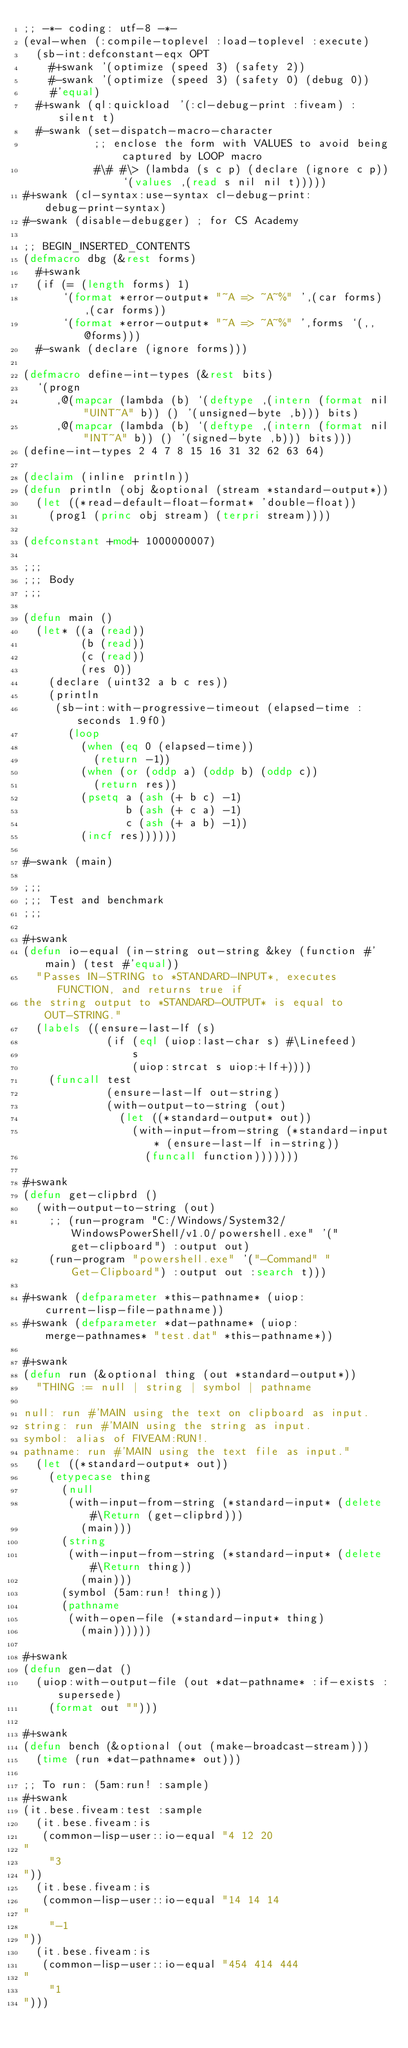Convert code to text. <code><loc_0><loc_0><loc_500><loc_500><_Lisp_>;; -*- coding: utf-8 -*-
(eval-when (:compile-toplevel :load-toplevel :execute)
  (sb-int:defconstant-eqx OPT
    #+swank '(optimize (speed 3) (safety 2))
    #-swank '(optimize (speed 3) (safety 0) (debug 0))
    #'equal)
  #+swank (ql:quickload '(:cl-debug-print :fiveam) :silent t)
  #-swank (set-dispatch-macro-character
           ;; enclose the form with VALUES to avoid being captured by LOOP macro
           #\# #\> (lambda (s c p) (declare (ignore c p)) `(values ,(read s nil nil t)))))
#+swank (cl-syntax:use-syntax cl-debug-print:debug-print-syntax)
#-swank (disable-debugger) ; for CS Academy

;; BEGIN_INSERTED_CONTENTS
(defmacro dbg (&rest forms)
  #+swank
  (if (= (length forms) 1)
      `(format *error-output* "~A => ~A~%" ',(car forms) ,(car forms))
      `(format *error-output* "~A => ~A~%" ',forms `(,,@forms)))
  #-swank (declare (ignore forms)))

(defmacro define-int-types (&rest bits)
  `(progn
     ,@(mapcar (lambda (b) `(deftype ,(intern (format nil "UINT~A" b)) () '(unsigned-byte ,b))) bits)
     ,@(mapcar (lambda (b) `(deftype ,(intern (format nil "INT~A" b)) () '(signed-byte ,b))) bits)))
(define-int-types 2 4 7 8 15 16 31 32 62 63 64)

(declaim (inline println))
(defun println (obj &optional (stream *standard-output*))
  (let ((*read-default-float-format* 'double-float))
    (prog1 (princ obj stream) (terpri stream))))

(defconstant +mod+ 1000000007)

;;;
;;; Body
;;;

(defun main ()
  (let* ((a (read))
         (b (read))
         (c (read))
         (res 0))
    (declare (uint32 a b c res))
    (println
     (sb-int:with-progressive-timeout (elapsed-time :seconds 1.9f0)
       (loop
         (when (eq 0 (elapsed-time))
           (return -1))
         (when (or (oddp a) (oddp b) (oddp c))
           (return res))
         (psetq a (ash (+ b c) -1)
                b (ash (+ c a) -1)
                c (ash (+ a b) -1))
         (incf res))))))

#-swank (main)

;;;
;;; Test and benchmark
;;;

#+swank
(defun io-equal (in-string out-string &key (function #'main) (test #'equal))
  "Passes IN-STRING to *STANDARD-INPUT*, executes FUNCTION, and returns true if
the string output to *STANDARD-OUTPUT* is equal to OUT-STRING."
  (labels ((ensure-last-lf (s)
             (if (eql (uiop:last-char s) #\Linefeed)
                 s
                 (uiop:strcat s uiop:+lf+))))
    (funcall test
             (ensure-last-lf out-string)
             (with-output-to-string (out)
               (let ((*standard-output* out))
                 (with-input-from-string (*standard-input* (ensure-last-lf in-string))
                   (funcall function)))))))

#+swank
(defun get-clipbrd ()
  (with-output-to-string (out)
    ;; (run-program "C:/Windows/System32/WindowsPowerShell/v1.0/powershell.exe" '("get-clipboard") :output out)
    (run-program "powershell.exe" '("-Command" "Get-Clipboard") :output out :search t)))

#+swank (defparameter *this-pathname* (uiop:current-lisp-file-pathname))
#+swank (defparameter *dat-pathname* (uiop:merge-pathnames* "test.dat" *this-pathname*))

#+swank
(defun run (&optional thing (out *standard-output*))
  "THING := null | string | symbol | pathname

null: run #'MAIN using the text on clipboard as input.
string: run #'MAIN using the string as input.
symbol: alias of FIVEAM:RUN!.
pathname: run #'MAIN using the text file as input."
  (let ((*standard-output* out))
    (etypecase thing
      (null
       (with-input-from-string (*standard-input* (delete #\Return (get-clipbrd)))
         (main)))
      (string
       (with-input-from-string (*standard-input* (delete #\Return thing))
         (main)))
      (symbol (5am:run! thing))
      (pathname
       (with-open-file (*standard-input* thing)
         (main))))))

#+swank
(defun gen-dat ()
  (uiop:with-output-file (out *dat-pathname* :if-exists :supersede)
    (format out "")))

#+swank
(defun bench (&optional (out (make-broadcast-stream)))
  (time (run *dat-pathname* out)))

;; To run: (5am:run! :sample)
#+swank
(it.bese.fiveam:test :sample
  (it.bese.fiveam:is
   (common-lisp-user::io-equal "4 12 20
"
    "3
"))
  (it.bese.fiveam:is
   (common-lisp-user::io-equal "14 14 14
"
    "-1
"))
  (it.bese.fiveam:is
   (common-lisp-user::io-equal "454 414 444
"
    "1
")))
</code> 